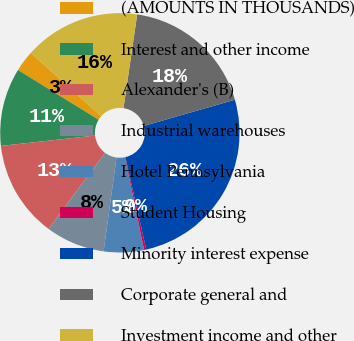<chart> <loc_0><loc_0><loc_500><loc_500><pie_chart><fcel>(AMOUNTS IN THOUSANDS)<fcel>Interest and other income<fcel>Alexander's (B)<fcel>Industrial warehouses<fcel>Hotel Pennsylvania<fcel>Student Housing<fcel>Minority interest expense<fcel>Corporate general and<fcel>Investment income and other<nl><fcel>2.85%<fcel>10.54%<fcel>13.1%<fcel>7.98%<fcel>5.42%<fcel>0.29%<fcel>25.92%<fcel>18.23%<fcel>15.67%<nl></chart> 